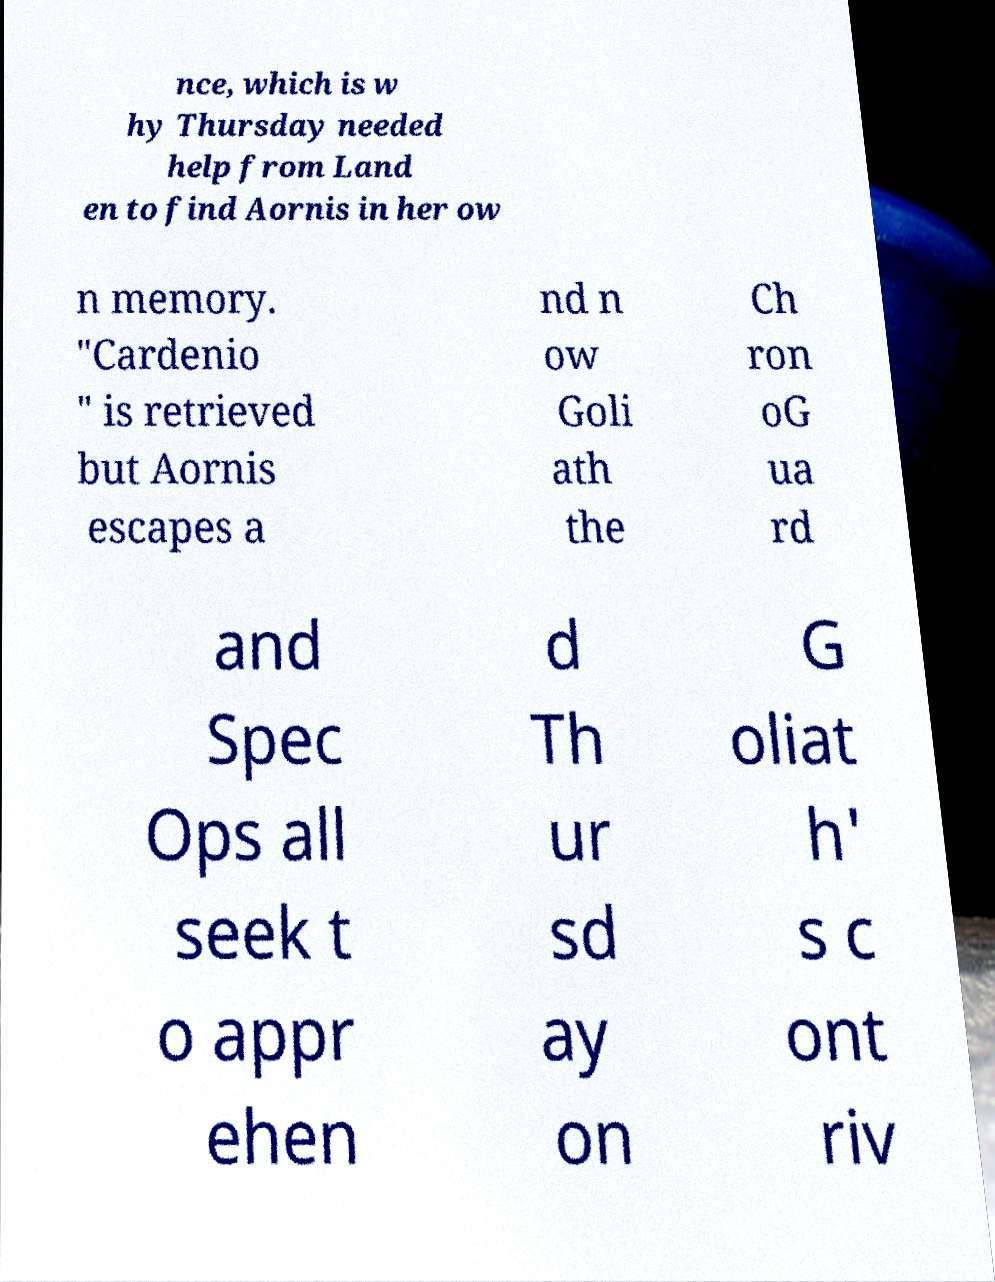I need the written content from this picture converted into text. Can you do that? nce, which is w hy Thursday needed help from Land en to find Aornis in her ow n memory. "Cardenio " is retrieved but Aornis escapes a nd n ow Goli ath the Ch ron oG ua rd and Spec Ops all seek t o appr ehen d Th ur sd ay on G oliat h' s c ont riv 